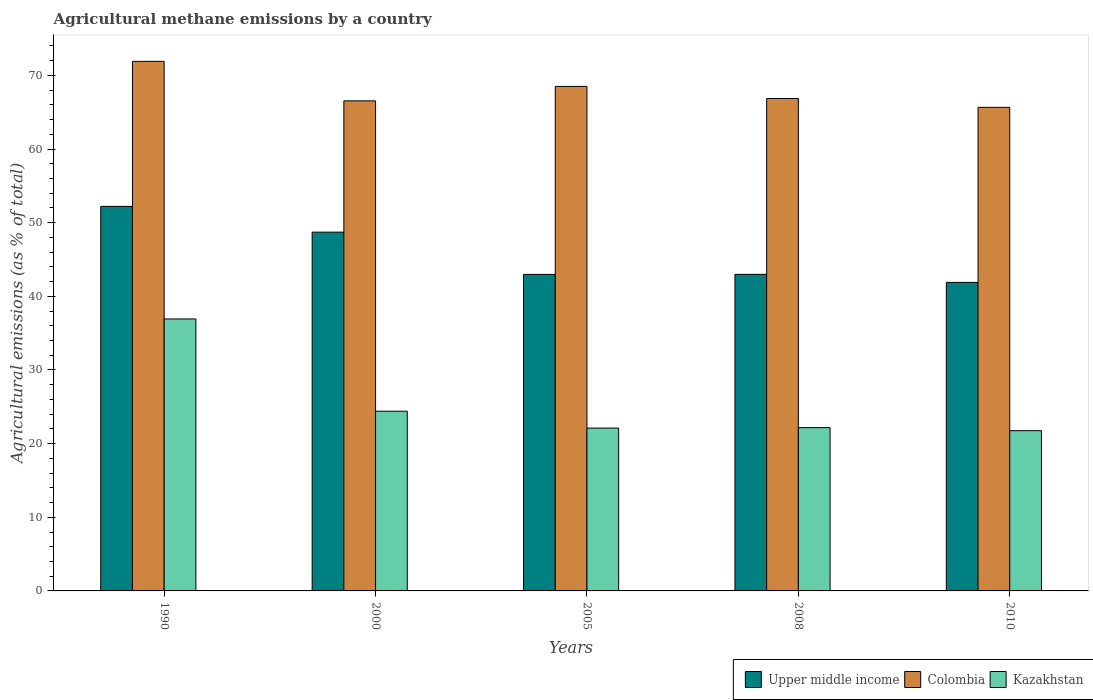How many different coloured bars are there?
Keep it short and to the point. 3. Are the number of bars per tick equal to the number of legend labels?
Make the answer very short. Yes. How many bars are there on the 5th tick from the right?
Give a very brief answer. 3. What is the label of the 5th group of bars from the left?
Provide a succinct answer. 2010. In how many cases, is the number of bars for a given year not equal to the number of legend labels?
Make the answer very short. 0. What is the amount of agricultural methane emitted in Colombia in 2010?
Your answer should be very brief. 65.66. Across all years, what is the maximum amount of agricultural methane emitted in Upper middle income?
Offer a very short reply. 52.21. Across all years, what is the minimum amount of agricultural methane emitted in Kazakhstan?
Provide a short and direct response. 21.76. In which year was the amount of agricultural methane emitted in Kazakhstan maximum?
Your answer should be very brief. 1990. What is the total amount of agricultural methane emitted in Upper middle income in the graph?
Offer a very short reply. 228.78. What is the difference between the amount of agricultural methane emitted in Colombia in 2000 and that in 2008?
Your answer should be compact. -0.32. What is the difference between the amount of agricultural methane emitted in Upper middle income in 2008 and the amount of agricultural methane emitted in Kazakhstan in 2005?
Give a very brief answer. 20.87. What is the average amount of agricultural methane emitted in Colombia per year?
Give a very brief answer. 67.89. In the year 2010, what is the difference between the amount of agricultural methane emitted in Colombia and amount of agricultural methane emitted in Upper middle income?
Give a very brief answer. 23.77. In how many years, is the amount of agricultural methane emitted in Kazakhstan greater than 30 %?
Keep it short and to the point. 1. What is the ratio of the amount of agricultural methane emitted in Kazakhstan in 2005 to that in 2010?
Your response must be concise. 1.02. What is the difference between the highest and the second highest amount of agricultural methane emitted in Kazakhstan?
Give a very brief answer. 12.53. What is the difference between the highest and the lowest amount of agricultural methane emitted in Upper middle income?
Make the answer very short. 10.32. Is the sum of the amount of agricultural methane emitted in Kazakhstan in 2000 and 2008 greater than the maximum amount of agricultural methane emitted in Upper middle income across all years?
Provide a succinct answer. No. What does the 3rd bar from the left in 2005 represents?
Provide a short and direct response. Kazakhstan. What does the 1st bar from the right in 1990 represents?
Provide a succinct answer. Kazakhstan. Is it the case that in every year, the sum of the amount of agricultural methane emitted in Upper middle income and amount of agricultural methane emitted in Kazakhstan is greater than the amount of agricultural methane emitted in Colombia?
Your answer should be very brief. No. How many years are there in the graph?
Your answer should be compact. 5. Does the graph contain any zero values?
Your answer should be compact. No. Where does the legend appear in the graph?
Offer a terse response. Bottom right. How many legend labels are there?
Your answer should be compact. 3. How are the legend labels stacked?
Offer a very short reply. Horizontal. What is the title of the graph?
Keep it short and to the point. Agricultural methane emissions by a country. What is the label or title of the X-axis?
Make the answer very short. Years. What is the label or title of the Y-axis?
Offer a very short reply. Agricultural emissions (as % of total). What is the Agricultural emissions (as % of total) in Upper middle income in 1990?
Keep it short and to the point. 52.21. What is the Agricultural emissions (as % of total) in Colombia in 1990?
Your answer should be very brief. 71.91. What is the Agricultural emissions (as % of total) of Kazakhstan in 1990?
Offer a terse response. 36.93. What is the Agricultural emissions (as % of total) in Upper middle income in 2000?
Keep it short and to the point. 48.72. What is the Agricultural emissions (as % of total) in Colombia in 2000?
Your response must be concise. 66.54. What is the Agricultural emissions (as % of total) in Kazakhstan in 2000?
Offer a very short reply. 24.4. What is the Agricultural emissions (as % of total) in Upper middle income in 2005?
Ensure brevity in your answer.  42.98. What is the Agricultural emissions (as % of total) in Colombia in 2005?
Ensure brevity in your answer.  68.5. What is the Agricultural emissions (as % of total) of Kazakhstan in 2005?
Your response must be concise. 22.11. What is the Agricultural emissions (as % of total) of Upper middle income in 2008?
Your response must be concise. 42.99. What is the Agricultural emissions (as % of total) of Colombia in 2008?
Keep it short and to the point. 66.86. What is the Agricultural emissions (as % of total) in Kazakhstan in 2008?
Your answer should be very brief. 22.17. What is the Agricultural emissions (as % of total) in Upper middle income in 2010?
Your answer should be compact. 41.89. What is the Agricultural emissions (as % of total) of Colombia in 2010?
Give a very brief answer. 65.66. What is the Agricultural emissions (as % of total) in Kazakhstan in 2010?
Your response must be concise. 21.76. Across all years, what is the maximum Agricultural emissions (as % of total) in Upper middle income?
Make the answer very short. 52.21. Across all years, what is the maximum Agricultural emissions (as % of total) in Colombia?
Make the answer very short. 71.91. Across all years, what is the maximum Agricultural emissions (as % of total) in Kazakhstan?
Your answer should be very brief. 36.93. Across all years, what is the minimum Agricultural emissions (as % of total) of Upper middle income?
Your answer should be compact. 41.89. Across all years, what is the minimum Agricultural emissions (as % of total) of Colombia?
Offer a very short reply. 65.66. Across all years, what is the minimum Agricultural emissions (as % of total) in Kazakhstan?
Make the answer very short. 21.76. What is the total Agricultural emissions (as % of total) in Upper middle income in the graph?
Provide a succinct answer. 228.78. What is the total Agricultural emissions (as % of total) in Colombia in the graph?
Give a very brief answer. 339.47. What is the total Agricultural emissions (as % of total) of Kazakhstan in the graph?
Make the answer very short. 127.37. What is the difference between the Agricultural emissions (as % of total) in Upper middle income in 1990 and that in 2000?
Ensure brevity in your answer.  3.5. What is the difference between the Agricultural emissions (as % of total) of Colombia in 1990 and that in 2000?
Your answer should be compact. 5.36. What is the difference between the Agricultural emissions (as % of total) in Kazakhstan in 1990 and that in 2000?
Your response must be concise. 12.53. What is the difference between the Agricultural emissions (as % of total) of Upper middle income in 1990 and that in 2005?
Provide a succinct answer. 9.24. What is the difference between the Agricultural emissions (as % of total) in Colombia in 1990 and that in 2005?
Provide a short and direct response. 3.4. What is the difference between the Agricultural emissions (as % of total) in Kazakhstan in 1990 and that in 2005?
Provide a succinct answer. 14.82. What is the difference between the Agricultural emissions (as % of total) in Upper middle income in 1990 and that in 2008?
Offer a terse response. 9.23. What is the difference between the Agricultural emissions (as % of total) of Colombia in 1990 and that in 2008?
Offer a terse response. 5.04. What is the difference between the Agricultural emissions (as % of total) of Kazakhstan in 1990 and that in 2008?
Ensure brevity in your answer.  14.76. What is the difference between the Agricultural emissions (as % of total) in Upper middle income in 1990 and that in 2010?
Offer a very short reply. 10.32. What is the difference between the Agricultural emissions (as % of total) in Colombia in 1990 and that in 2010?
Offer a terse response. 6.25. What is the difference between the Agricultural emissions (as % of total) in Kazakhstan in 1990 and that in 2010?
Your answer should be compact. 15.17. What is the difference between the Agricultural emissions (as % of total) in Upper middle income in 2000 and that in 2005?
Provide a succinct answer. 5.74. What is the difference between the Agricultural emissions (as % of total) of Colombia in 2000 and that in 2005?
Your response must be concise. -1.96. What is the difference between the Agricultural emissions (as % of total) in Kazakhstan in 2000 and that in 2005?
Keep it short and to the point. 2.29. What is the difference between the Agricultural emissions (as % of total) in Upper middle income in 2000 and that in 2008?
Provide a succinct answer. 5.73. What is the difference between the Agricultural emissions (as % of total) in Colombia in 2000 and that in 2008?
Your response must be concise. -0.32. What is the difference between the Agricultural emissions (as % of total) of Kazakhstan in 2000 and that in 2008?
Make the answer very short. 2.23. What is the difference between the Agricultural emissions (as % of total) in Upper middle income in 2000 and that in 2010?
Your answer should be very brief. 6.82. What is the difference between the Agricultural emissions (as % of total) of Colombia in 2000 and that in 2010?
Ensure brevity in your answer.  0.88. What is the difference between the Agricultural emissions (as % of total) of Kazakhstan in 2000 and that in 2010?
Offer a very short reply. 2.64. What is the difference between the Agricultural emissions (as % of total) in Upper middle income in 2005 and that in 2008?
Offer a very short reply. -0.01. What is the difference between the Agricultural emissions (as % of total) of Colombia in 2005 and that in 2008?
Keep it short and to the point. 1.64. What is the difference between the Agricultural emissions (as % of total) of Kazakhstan in 2005 and that in 2008?
Your answer should be very brief. -0.06. What is the difference between the Agricultural emissions (as % of total) of Upper middle income in 2005 and that in 2010?
Offer a terse response. 1.08. What is the difference between the Agricultural emissions (as % of total) in Colombia in 2005 and that in 2010?
Your answer should be very brief. 2.84. What is the difference between the Agricultural emissions (as % of total) of Kazakhstan in 2005 and that in 2010?
Your answer should be very brief. 0.36. What is the difference between the Agricultural emissions (as % of total) of Upper middle income in 2008 and that in 2010?
Your response must be concise. 1.1. What is the difference between the Agricultural emissions (as % of total) of Colombia in 2008 and that in 2010?
Provide a succinct answer. 1.2. What is the difference between the Agricultural emissions (as % of total) of Kazakhstan in 2008 and that in 2010?
Make the answer very short. 0.41. What is the difference between the Agricultural emissions (as % of total) of Upper middle income in 1990 and the Agricultural emissions (as % of total) of Colombia in 2000?
Make the answer very short. -14.33. What is the difference between the Agricultural emissions (as % of total) in Upper middle income in 1990 and the Agricultural emissions (as % of total) in Kazakhstan in 2000?
Provide a succinct answer. 27.81. What is the difference between the Agricultural emissions (as % of total) of Colombia in 1990 and the Agricultural emissions (as % of total) of Kazakhstan in 2000?
Provide a short and direct response. 47.5. What is the difference between the Agricultural emissions (as % of total) in Upper middle income in 1990 and the Agricultural emissions (as % of total) in Colombia in 2005?
Provide a succinct answer. -16.29. What is the difference between the Agricultural emissions (as % of total) in Upper middle income in 1990 and the Agricultural emissions (as % of total) in Kazakhstan in 2005?
Make the answer very short. 30.1. What is the difference between the Agricultural emissions (as % of total) of Colombia in 1990 and the Agricultural emissions (as % of total) of Kazakhstan in 2005?
Offer a terse response. 49.79. What is the difference between the Agricultural emissions (as % of total) of Upper middle income in 1990 and the Agricultural emissions (as % of total) of Colombia in 2008?
Make the answer very short. -14.65. What is the difference between the Agricultural emissions (as % of total) of Upper middle income in 1990 and the Agricultural emissions (as % of total) of Kazakhstan in 2008?
Your answer should be compact. 30.04. What is the difference between the Agricultural emissions (as % of total) of Colombia in 1990 and the Agricultural emissions (as % of total) of Kazakhstan in 2008?
Make the answer very short. 49.73. What is the difference between the Agricultural emissions (as % of total) in Upper middle income in 1990 and the Agricultural emissions (as % of total) in Colombia in 2010?
Give a very brief answer. -13.45. What is the difference between the Agricultural emissions (as % of total) of Upper middle income in 1990 and the Agricultural emissions (as % of total) of Kazakhstan in 2010?
Make the answer very short. 30.46. What is the difference between the Agricultural emissions (as % of total) of Colombia in 1990 and the Agricultural emissions (as % of total) of Kazakhstan in 2010?
Ensure brevity in your answer.  50.15. What is the difference between the Agricultural emissions (as % of total) in Upper middle income in 2000 and the Agricultural emissions (as % of total) in Colombia in 2005?
Ensure brevity in your answer.  -19.79. What is the difference between the Agricultural emissions (as % of total) in Upper middle income in 2000 and the Agricultural emissions (as % of total) in Kazakhstan in 2005?
Offer a terse response. 26.6. What is the difference between the Agricultural emissions (as % of total) of Colombia in 2000 and the Agricultural emissions (as % of total) of Kazakhstan in 2005?
Provide a short and direct response. 44.43. What is the difference between the Agricultural emissions (as % of total) in Upper middle income in 2000 and the Agricultural emissions (as % of total) in Colombia in 2008?
Your response must be concise. -18.15. What is the difference between the Agricultural emissions (as % of total) in Upper middle income in 2000 and the Agricultural emissions (as % of total) in Kazakhstan in 2008?
Make the answer very short. 26.55. What is the difference between the Agricultural emissions (as % of total) of Colombia in 2000 and the Agricultural emissions (as % of total) of Kazakhstan in 2008?
Provide a succinct answer. 44.37. What is the difference between the Agricultural emissions (as % of total) in Upper middle income in 2000 and the Agricultural emissions (as % of total) in Colombia in 2010?
Offer a very short reply. -16.94. What is the difference between the Agricultural emissions (as % of total) of Upper middle income in 2000 and the Agricultural emissions (as % of total) of Kazakhstan in 2010?
Your answer should be very brief. 26.96. What is the difference between the Agricultural emissions (as % of total) in Colombia in 2000 and the Agricultural emissions (as % of total) in Kazakhstan in 2010?
Make the answer very short. 44.79. What is the difference between the Agricultural emissions (as % of total) of Upper middle income in 2005 and the Agricultural emissions (as % of total) of Colombia in 2008?
Keep it short and to the point. -23.89. What is the difference between the Agricultural emissions (as % of total) of Upper middle income in 2005 and the Agricultural emissions (as % of total) of Kazakhstan in 2008?
Provide a short and direct response. 20.8. What is the difference between the Agricultural emissions (as % of total) of Colombia in 2005 and the Agricultural emissions (as % of total) of Kazakhstan in 2008?
Your response must be concise. 46.33. What is the difference between the Agricultural emissions (as % of total) of Upper middle income in 2005 and the Agricultural emissions (as % of total) of Colombia in 2010?
Give a very brief answer. -22.68. What is the difference between the Agricultural emissions (as % of total) in Upper middle income in 2005 and the Agricultural emissions (as % of total) in Kazakhstan in 2010?
Offer a very short reply. 21.22. What is the difference between the Agricultural emissions (as % of total) of Colombia in 2005 and the Agricultural emissions (as % of total) of Kazakhstan in 2010?
Your answer should be compact. 46.75. What is the difference between the Agricultural emissions (as % of total) in Upper middle income in 2008 and the Agricultural emissions (as % of total) in Colombia in 2010?
Provide a succinct answer. -22.67. What is the difference between the Agricultural emissions (as % of total) of Upper middle income in 2008 and the Agricultural emissions (as % of total) of Kazakhstan in 2010?
Ensure brevity in your answer.  21.23. What is the difference between the Agricultural emissions (as % of total) of Colombia in 2008 and the Agricultural emissions (as % of total) of Kazakhstan in 2010?
Your answer should be compact. 45.11. What is the average Agricultural emissions (as % of total) in Upper middle income per year?
Ensure brevity in your answer.  45.76. What is the average Agricultural emissions (as % of total) in Colombia per year?
Offer a terse response. 67.89. What is the average Agricultural emissions (as % of total) in Kazakhstan per year?
Provide a succinct answer. 25.47. In the year 1990, what is the difference between the Agricultural emissions (as % of total) of Upper middle income and Agricultural emissions (as % of total) of Colombia?
Give a very brief answer. -19.69. In the year 1990, what is the difference between the Agricultural emissions (as % of total) in Upper middle income and Agricultural emissions (as % of total) in Kazakhstan?
Offer a very short reply. 15.29. In the year 1990, what is the difference between the Agricultural emissions (as % of total) of Colombia and Agricultural emissions (as % of total) of Kazakhstan?
Your answer should be very brief. 34.98. In the year 2000, what is the difference between the Agricultural emissions (as % of total) in Upper middle income and Agricultural emissions (as % of total) in Colombia?
Offer a very short reply. -17.83. In the year 2000, what is the difference between the Agricultural emissions (as % of total) of Upper middle income and Agricultural emissions (as % of total) of Kazakhstan?
Offer a terse response. 24.32. In the year 2000, what is the difference between the Agricultural emissions (as % of total) of Colombia and Agricultural emissions (as % of total) of Kazakhstan?
Your answer should be compact. 42.14. In the year 2005, what is the difference between the Agricultural emissions (as % of total) of Upper middle income and Agricultural emissions (as % of total) of Colombia?
Offer a terse response. -25.53. In the year 2005, what is the difference between the Agricultural emissions (as % of total) of Upper middle income and Agricultural emissions (as % of total) of Kazakhstan?
Your answer should be compact. 20.86. In the year 2005, what is the difference between the Agricultural emissions (as % of total) in Colombia and Agricultural emissions (as % of total) in Kazakhstan?
Ensure brevity in your answer.  46.39. In the year 2008, what is the difference between the Agricultural emissions (as % of total) in Upper middle income and Agricultural emissions (as % of total) in Colombia?
Keep it short and to the point. -23.88. In the year 2008, what is the difference between the Agricultural emissions (as % of total) in Upper middle income and Agricultural emissions (as % of total) in Kazakhstan?
Offer a terse response. 20.82. In the year 2008, what is the difference between the Agricultural emissions (as % of total) of Colombia and Agricultural emissions (as % of total) of Kazakhstan?
Make the answer very short. 44.69. In the year 2010, what is the difference between the Agricultural emissions (as % of total) in Upper middle income and Agricultural emissions (as % of total) in Colombia?
Your response must be concise. -23.77. In the year 2010, what is the difference between the Agricultural emissions (as % of total) in Upper middle income and Agricultural emissions (as % of total) in Kazakhstan?
Your answer should be very brief. 20.13. In the year 2010, what is the difference between the Agricultural emissions (as % of total) in Colombia and Agricultural emissions (as % of total) in Kazakhstan?
Provide a short and direct response. 43.9. What is the ratio of the Agricultural emissions (as % of total) of Upper middle income in 1990 to that in 2000?
Provide a short and direct response. 1.07. What is the ratio of the Agricultural emissions (as % of total) of Colombia in 1990 to that in 2000?
Your answer should be compact. 1.08. What is the ratio of the Agricultural emissions (as % of total) in Kazakhstan in 1990 to that in 2000?
Provide a succinct answer. 1.51. What is the ratio of the Agricultural emissions (as % of total) in Upper middle income in 1990 to that in 2005?
Provide a succinct answer. 1.22. What is the ratio of the Agricultural emissions (as % of total) of Colombia in 1990 to that in 2005?
Give a very brief answer. 1.05. What is the ratio of the Agricultural emissions (as % of total) of Kazakhstan in 1990 to that in 2005?
Make the answer very short. 1.67. What is the ratio of the Agricultural emissions (as % of total) in Upper middle income in 1990 to that in 2008?
Ensure brevity in your answer.  1.21. What is the ratio of the Agricultural emissions (as % of total) in Colombia in 1990 to that in 2008?
Keep it short and to the point. 1.08. What is the ratio of the Agricultural emissions (as % of total) of Kazakhstan in 1990 to that in 2008?
Offer a terse response. 1.67. What is the ratio of the Agricultural emissions (as % of total) of Upper middle income in 1990 to that in 2010?
Your answer should be compact. 1.25. What is the ratio of the Agricultural emissions (as % of total) in Colombia in 1990 to that in 2010?
Your answer should be very brief. 1.1. What is the ratio of the Agricultural emissions (as % of total) in Kazakhstan in 1990 to that in 2010?
Your response must be concise. 1.7. What is the ratio of the Agricultural emissions (as % of total) in Upper middle income in 2000 to that in 2005?
Give a very brief answer. 1.13. What is the ratio of the Agricultural emissions (as % of total) in Colombia in 2000 to that in 2005?
Provide a short and direct response. 0.97. What is the ratio of the Agricultural emissions (as % of total) of Kazakhstan in 2000 to that in 2005?
Your answer should be compact. 1.1. What is the ratio of the Agricultural emissions (as % of total) of Upper middle income in 2000 to that in 2008?
Provide a short and direct response. 1.13. What is the ratio of the Agricultural emissions (as % of total) in Kazakhstan in 2000 to that in 2008?
Provide a short and direct response. 1.1. What is the ratio of the Agricultural emissions (as % of total) in Upper middle income in 2000 to that in 2010?
Make the answer very short. 1.16. What is the ratio of the Agricultural emissions (as % of total) in Colombia in 2000 to that in 2010?
Offer a terse response. 1.01. What is the ratio of the Agricultural emissions (as % of total) of Kazakhstan in 2000 to that in 2010?
Make the answer very short. 1.12. What is the ratio of the Agricultural emissions (as % of total) of Upper middle income in 2005 to that in 2008?
Offer a very short reply. 1. What is the ratio of the Agricultural emissions (as % of total) in Colombia in 2005 to that in 2008?
Your answer should be compact. 1.02. What is the ratio of the Agricultural emissions (as % of total) of Kazakhstan in 2005 to that in 2008?
Offer a very short reply. 1. What is the ratio of the Agricultural emissions (as % of total) of Upper middle income in 2005 to that in 2010?
Give a very brief answer. 1.03. What is the ratio of the Agricultural emissions (as % of total) in Colombia in 2005 to that in 2010?
Offer a terse response. 1.04. What is the ratio of the Agricultural emissions (as % of total) in Kazakhstan in 2005 to that in 2010?
Make the answer very short. 1.02. What is the ratio of the Agricultural emissions (as % of total) in Upper middle income in 2008 to that in 2010?
Your response must be concise. 1.03. What is the ratio of the Agricultural emissions (as % of total) in Colombia in 2008 to that in 2010?
Offer a very short reply. 1.02. What is the ratio of the Agricultural emissions (as % of total) in Kazakhstan in 2008 to that in 2010?
Your answer should be very brief. 1.02. What is the difference between the highest and the second highest Agricultural emissions (as % of total) in Upper middle income?
Make the answer very short. 3.5. What is the difference between the highest and the second highest Agricultural emissions (as % of total) in Colombia?
Provide a short and direct response. 3.4. What is the difference between the highest and the second highest Agricultural emissions (as % of total) of Kazakhstan?
Provide a short and direct response. 12.53. What is the difference between the highest and the lowest Agricultural emissions (as % of total) of Upper middle income?
Your answer should be very brief. 10.32. What is the difference between the highest and the lowest Agricultural emissions (as % of total) of Colombia?
Make the answer very short. 6.25. What is the difference between the highest and the lowest Agricultural emissions (as % of total) in Kazakhstan?
Offer a terse response. 15.17. 